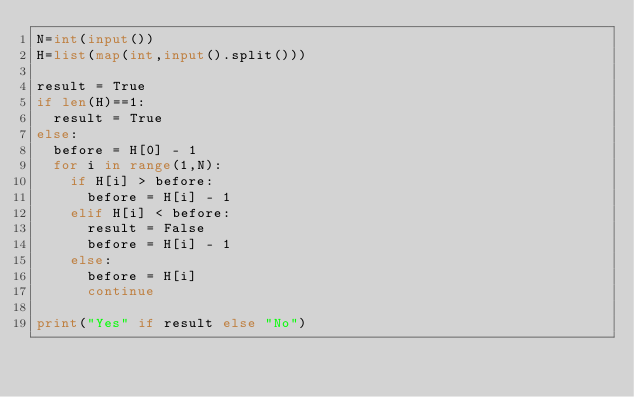Convert code to text. <code><loc_0><loc_0><loc_500><loc_500><_Python_>N=int(input())
H=list(map(int,input().split()))

result = True
if len(H)==1:
  result = True
else:
  before = H[0] - 1
  for i in range(1,N):
    if H[i] > before:
      before = H[i] - 1
    elif H[i] < before:
      result = False
      before = H[i] - 1
    else:
      before = H[i]
      continue
    
print("Yes" if result else "No")      
      
  


  </code> 